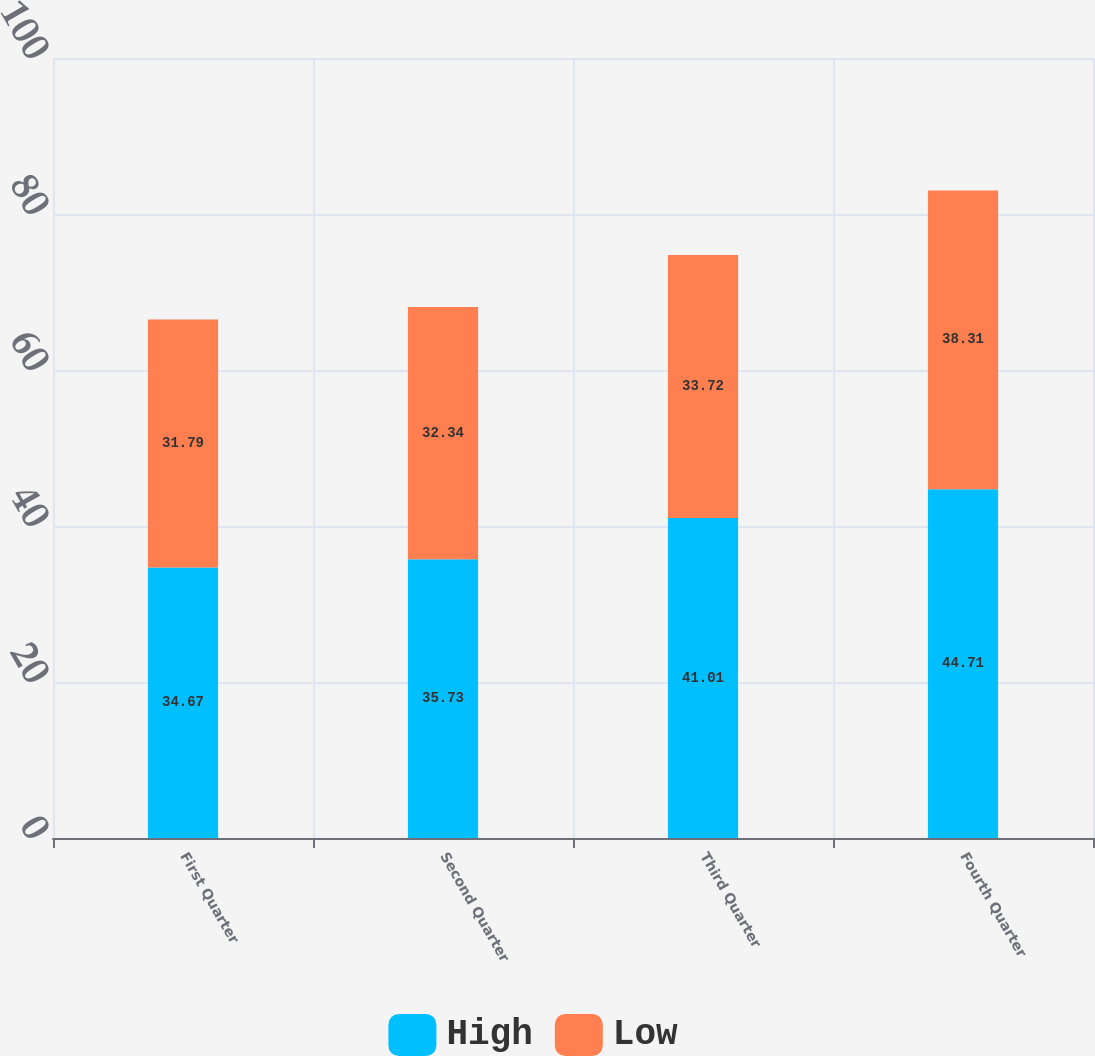Convert chart to OTSL. <chart><loc_0><loc_0><loc_500><loc_500><stacked_bar_chart><ecel><fcel>First Quarter<fcel>Second Quarter<fcel>Third Quarter<fcel>Fourth Quarter<nl><fcel>High<fcel>34.67<fcel>35.73<fcel>41.01<fcel>44.71<nl><fcel>Low<fcel>31.79<fcel>32.34<fcel>33.72<fcel>38.31<nl></chart> 